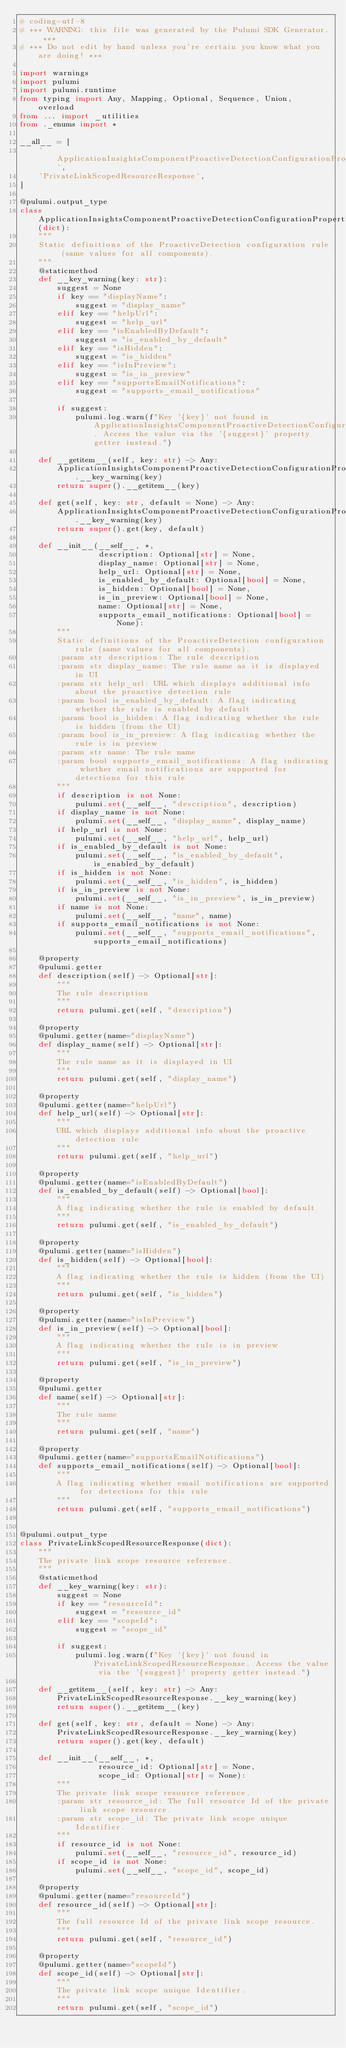Convert code to text. <code><loc_0><loc_0><loc_500><loc_500><_Python_># coding=utf-8
# *** WARNING: this file was generated by the Pulumi SDK Generator. ***
# *** Do not edit by hand unless you're certain you know what you are doing! ***

import warnings
import pulumi
import pulumi.runtime
from typing import Any, Mapping, Optional, Sequence, Union, overload
from ... import _utilities
from ._enums import *

__all__ = [
    'ApplicationInsightsComponentProactiveDetectionConfigurationPropertiesResponseRuleDefinitions',
    'PrivateLinkScopedResourceResponse',
]

@pulumi.output_type
class ApplicationInsightsComponentProactiveDetectionConfigurationPropertiesResponseRuleDefinitions(dict):
    """
    Static definitions of the ProactiveDetection configuration rule (same values for all components).
    """
    @staticmethod
    def __key_warning(key: str):
        suggest = None
        if key == "displayName":
            suggest = "display_name"
        elif key == "helpUrl":
            suggest = "help_url"
        elif key == "isEnabledByDefault":
            suggest = "is_enabled_by_default"
        elif key == "isHidden":
            suggest = "is_hidden"
        elif key == "isInPreview":
            suggest = "is_in_preview"
        elif key == "supportsEmailNotifications":
            suggest = "supports_email_notifications"

        if suggest:
            pulumi.log.warn(f"Key '{key}' not found in ApplicationInsightsComponentProactiveDetectionConfigurationPropertiesResponseRuleDefinitions. Access the value via the '{suggest}' property getter instead.")

    def __getitem__(self, key: str) -> Any:
        ApplicationInsightsComponentProactiveDetectionConfigurationPropertiesResponseRuleDefinitions.__key_warning(key)
        return super().__getitem__(key)

    def get(self, key: str, default = None) -> Any:
        ApplicationInsightsComponentProactiveDetectionConfigurationPropertiesResponseRuleDefinitions.__key_warning(key)
        return super().get(key, default)

    def __init__(__self__, *,
                 description: Optional[str] = None,
                 display_name: Optional[str] = None,
                 help_url: Optional[str] = None,
                 is_enabled_by_default: Optional[bool] = None,
                 is_hidden: Optional[bool] = None,
                 is_in_preview: Optional[bool] = None,
                 name: Optional[str] = None,
                 supports_email_notifications: Optional[bool] = None):
        """
        Static definitions of the ProactiveDetection configuration rule (same values for all components).
        :param str description: The rule description
        :param str display_name: The rule name as it is displayed in UI
        :param str help_url: URL which displays additional info about the proactive detection rule
        :param bool is_enabled_by_default: A flag indicating whether the rule is enabled by default
        :param bool is_hidden: A flag indicating whether the rule is hidden (from the UI)
        :param bool is_in_preview: A flag indicating whether the rule is in preview
        :param str name: The rule name
        :param bool supports_email_notifications: A flag indicating whether email notifications are supported for detections for this rule
        """
        if description is not None:
            pulumi.set(__self__, "description", description)
        if display_name is not None:
            pulumi.set(__self__, "display_name", display_name)
        if help_url is not None:
            pulumi.set(__self__, "help_url", help_url)
        if is_enabled_by_default is not None:
            pulumi.set(__self__, "is_enabled_by_default", is_enabled_by_default)
        if is_hidden is not None:
            pulumi.set(__self__, "is_hidden", is_hidden)
        if is_in_preview is not None:
            pulumi.set(__self__, "is_in_preview", is_in_preview)
        if name is not None:
            pulumi.set(__self__, "name", name)
        if supports_email_notifications is not None:
            pulumi.set(__self__, "supports_email_notifications", supports_email_notifications)

    @property
    @pulumi.getter
    def description(self) -> Optional[str]:
        """
        The rule description
        """
        return pulumi.get(self, "description")

    @property
    @pulumi.getter(name="displayName")
    def display_name(self) -> Optional[str]:
        """
        The rule name as it is displayed in UI
        """
        return pulumi.get(self, "display_name")

    @property
    @pulumi.getter(name="helpUrl")
    def help_url(self) -> Optional[str]:
        """
        URL which displays additional info about the proactive detection rule
        """
        return pulumi.get(self, "help_url")

    @property
    @pulumi.getter(name="isEnabledByDefault")
    def is_enabled_by_default(self) -> Optional[bool]:
        """
        A flag indicating whether the rule is enabled by default
        """
        return pulumi.get(self, "is_enabled_by_default")

    @property
    @pulumi.getter(name="isHidden")
    def is_hidden(self) -> Optional[bool]:
        """
        A flag indicating whether the rule is hidden (from the UI)
        """
        return pulumi.get(self, "is_hidden")

    @property
    @pulumi.getter(name="isInPreview")
    def is_in_preview(self) -> Optional[bool]:
        """
        A flag indicating whether the rule is in preview
        """
        return pulumi.get(self, "is_in_preview")

    @property
    @pulumi.getter
    def name(self) -> Optional[str]:
        """
        The rule name
        """
        return pulumi.get(self, "name")

    @property
    @pulumi.getter(name="supportsEmailNotifications")
    def supports_email_notifications(self) -> Optional[bool]:
        """
        A flag indicating whether email notifications are supported for detections for this rule
        """
        return pulumi.get(self, "supports_email_notifications")


@pulumi.output_type
class PrivateLinkScopedResourceResponse(dict):
    """
    The private link scope resource reference.
    """
    @staticmethod
    def __key_warning(key: str):
        suggest = None
        if key == "resourceId":
            suggest = "resource_id"
        elif key == "scopeId":
            suggest = "scope_id"

        if suggest:
            pulumi.log.warn(f"Key '{key}' not found in PrivateLinkScopedResourceResponse. Access the value via the '{suggest}' property getter instead.")

    def __getitem__(self, key: str) -> Any:
        PrivateLinkScopedResourceResponse.__key_warning(key)
        return super().__getitem__(key)

    def get(self, key: str, default = None) -> Any:
        PrivateLinkScopedResourceResponse.__key_warning(key)
        return super().get(key, default)

    def __init__(__self__, *,
                 resource_id: Optional[str] = None,
                 scope_id: Optional[str] = None):
        """
        The private link scope resource reference.
        :param str resource_id: The full resource Id of the private link scope resource.
        :param str scope_id: The private link scope unique Identifier.
        """
        if resource_id is not None:
            pulumi.set(__self__, "resource_id", resource_id)
        if scope_id is not None:
            pulumi.set(__self__, "scope_id", scope_id)

    @property
    @pulumi.getter(name="resourceId")
    def resource_id(self) -> Optional[str]:
        """
        The full resource Id of the private link scope resource.
        """
        return pulumi.get(self, "resource_id")

    @property
    @pulumi.getter(name="scopeId")
    def scope_id(self) -> Optional[str]:
        """
        The private link scope unique Identifier.
        """
        return pulumi.get(self, "scope_id")


</code> 